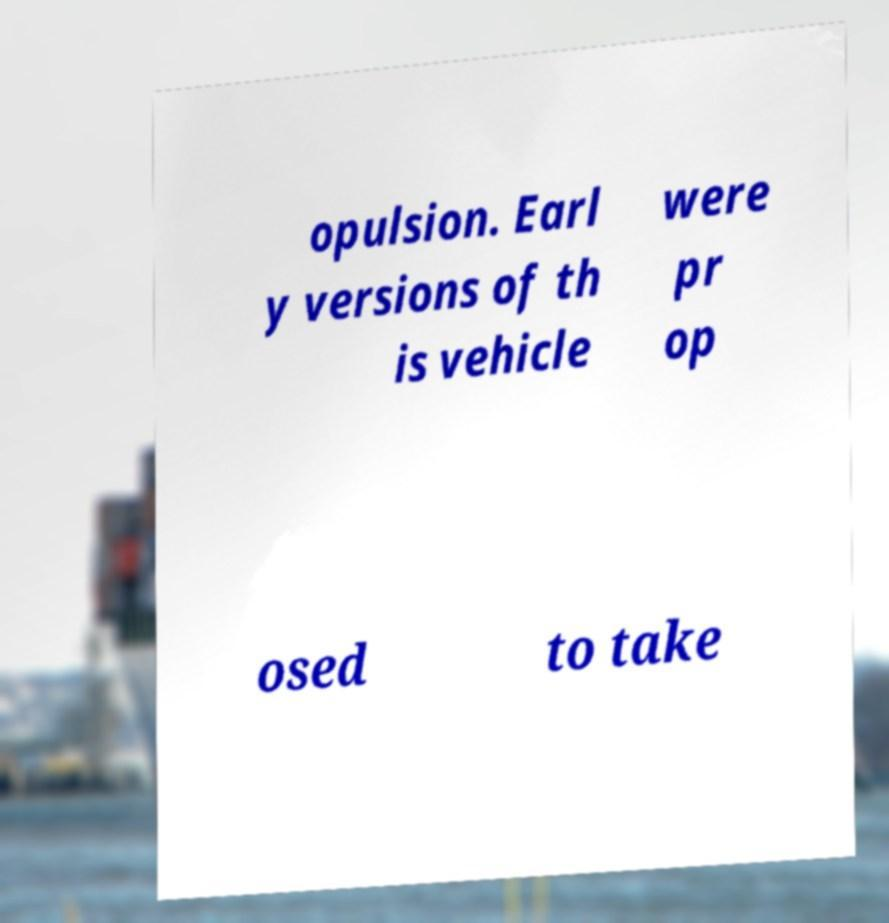What messages or text are displayed in this image? I need them in a readable, typed format. opulsion. Earl y versions of th is vehicle were pr op osed to take 